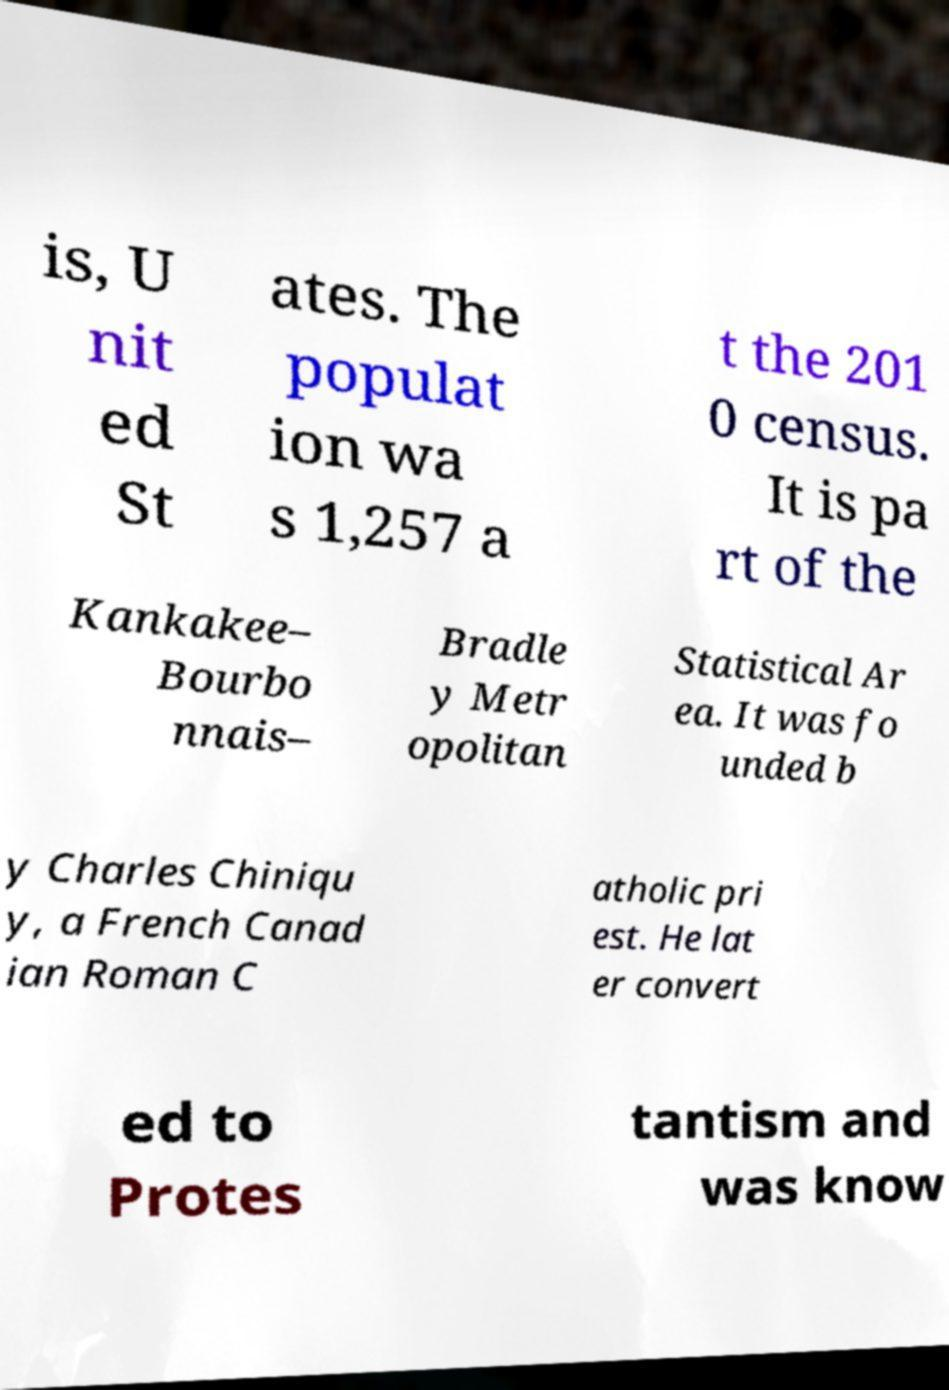I need the written content from this picture converted into text. Can you do that? is, U nit ed St ates. The populat ion wa s 1,257 a t the 201 0 census. It is pa rt of the Kankakee– Bourbo nnais– Bradle y Metr opolitan Statistical Ar ea. It was fo unded b y Charles Chiniqu y, a French Canad ian Roman C atholic pri est. He lat er convert ed to Protes tantism and was know 